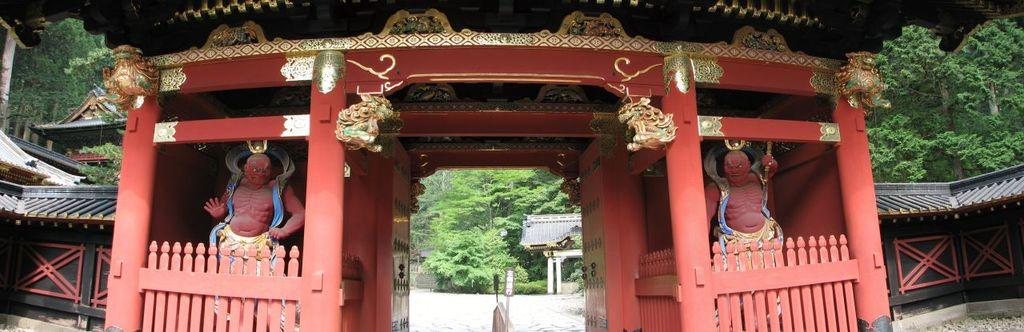What is the main feature of the arch in the image? The arch contains sculptures in the image. What structure can be seen on the left side of the image? There is a shelter house on the left side of the image. What type of natural elements are visible in the background of the image? There are trees in the background of the image. What type of grape is hanging from the arch in the image? There are no grapes present in the image; the arch contains sculptures. How does the throat of the sculpture in the arch appear in the image? There is no sculpture with a throat visible in the image. 